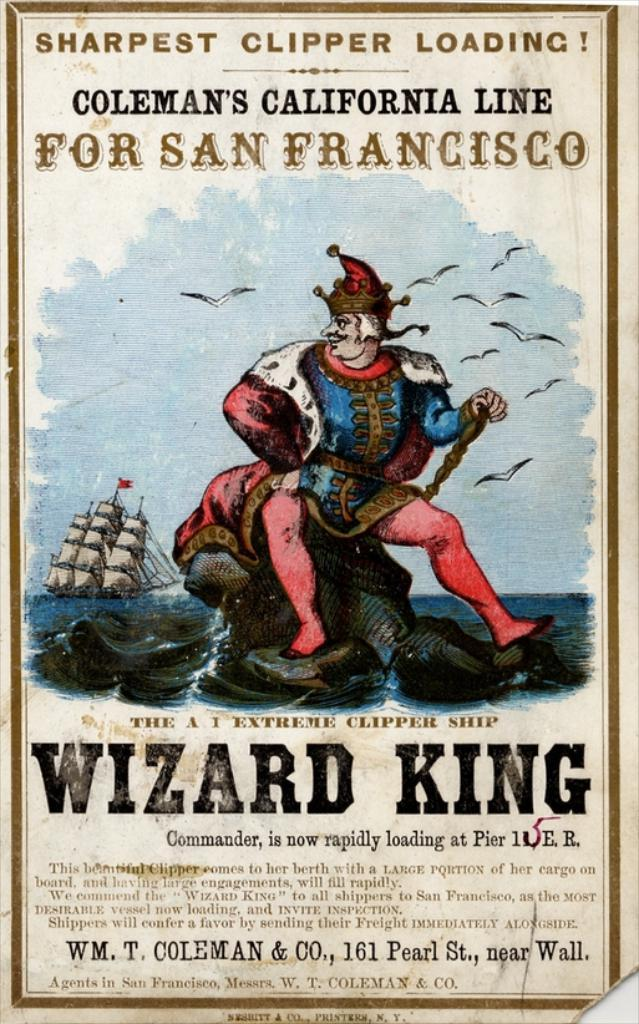<image>
Create a compact narrative representing the image presented. a poster that has the wizard king written on it 